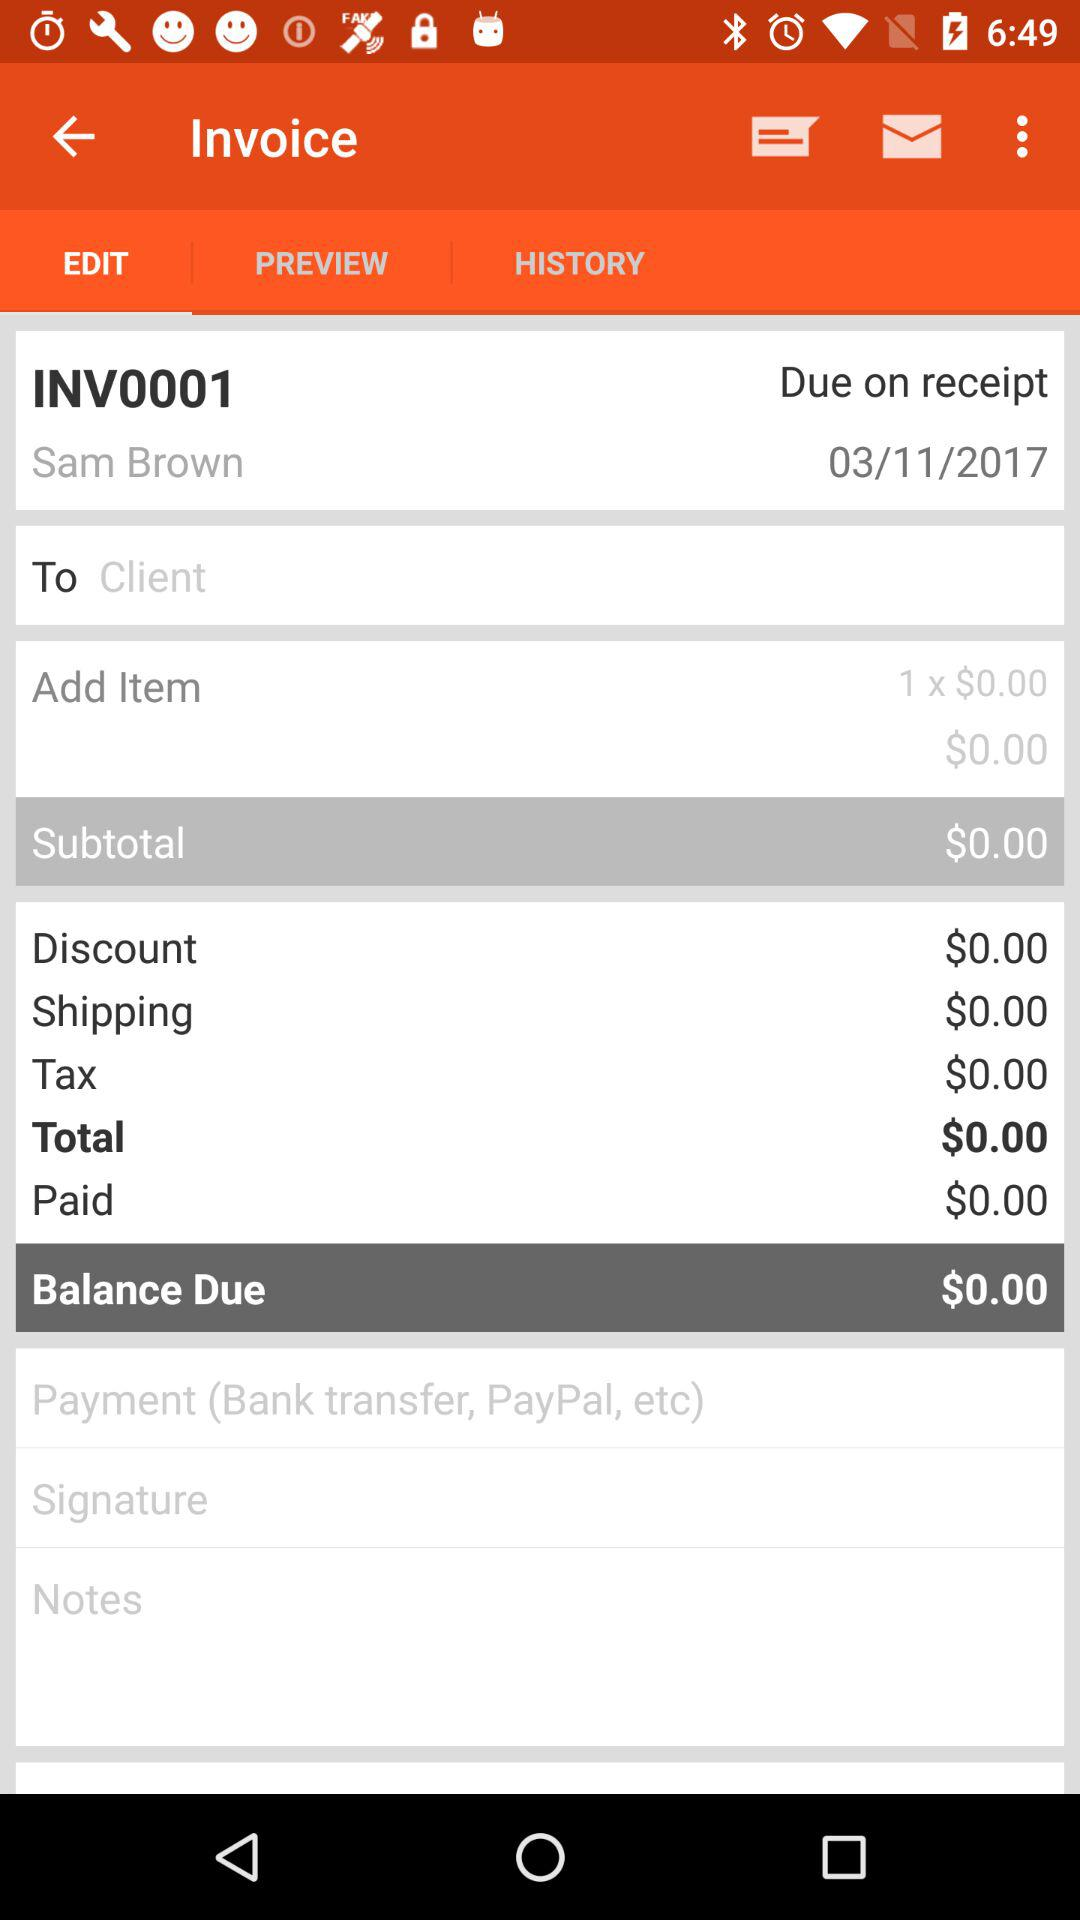What is the name of the user? The name of the user is "Sam Brown". 